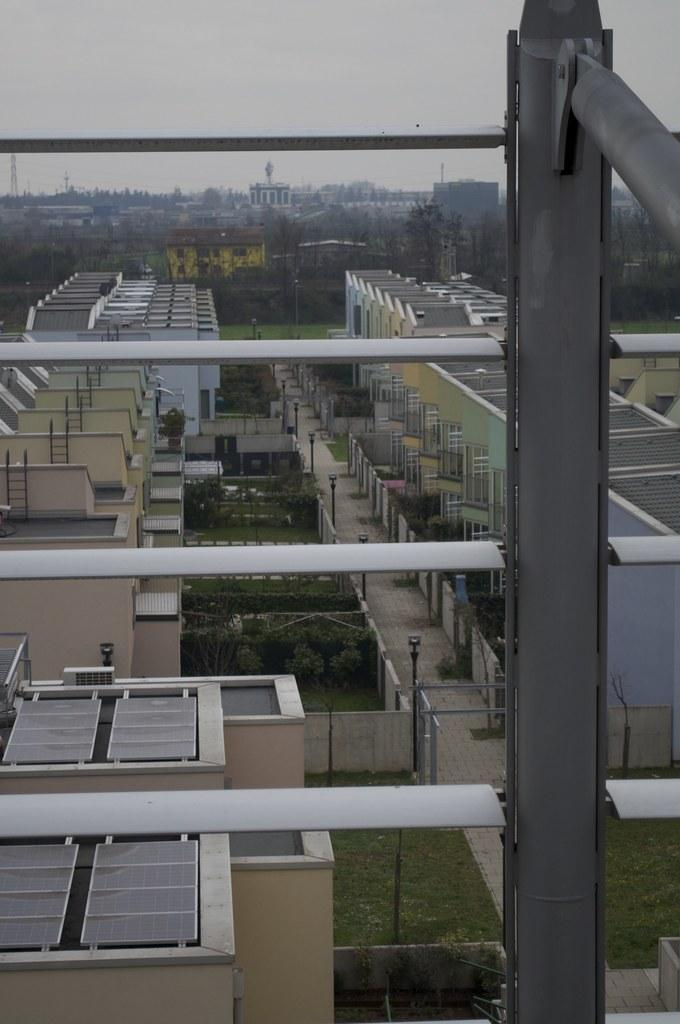What type of structures can be seen in the image? There are buildings in the image. What is the purpose of the fence in the image? The purpose of the fence is not specified, but it is present in the image. What are the poles used for in the image? The purpose of the poles is not specified, but they are present in the image. What type of vegetation is visible in the image? The grass is visible in the image. What objects can be found on the ground in the image? There are objects on the ground in the image, but their specific nature is not mentioned. What can be seen in the background of the image? There are trees and the sky visible in the background of the image. How many deer are visible in the image? There are no deer present in the image. What type of development is taking place in the image? The image does not depict any development or construction activities. 